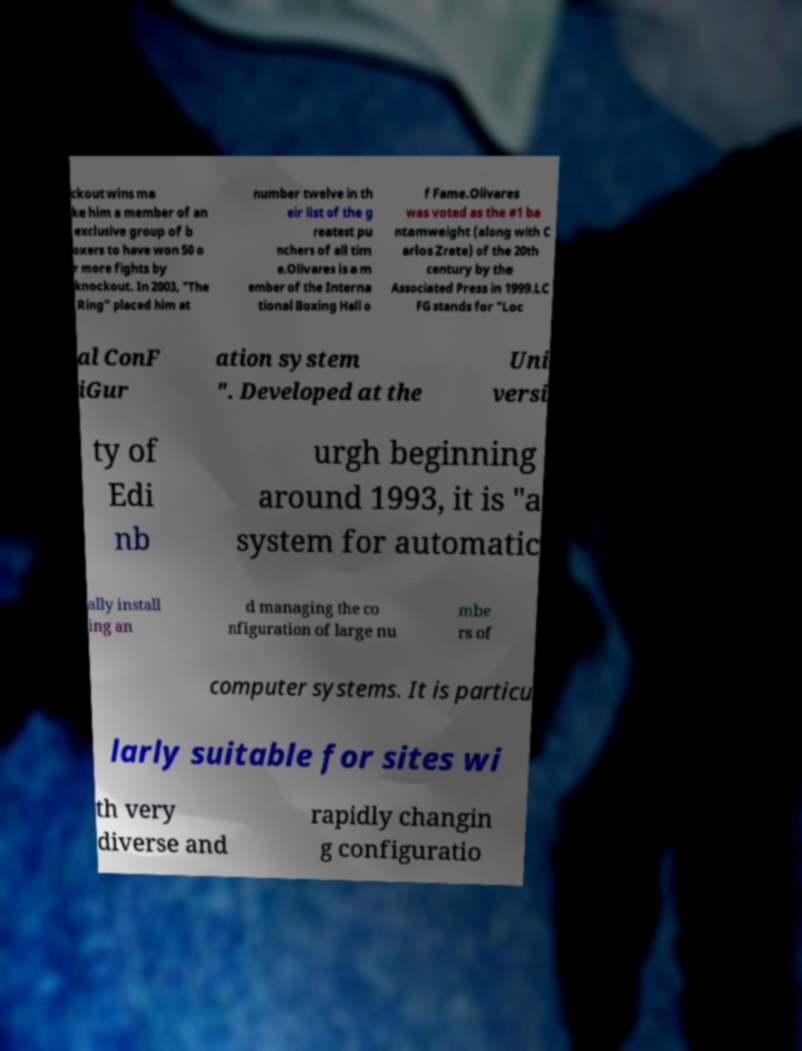I need the written content from this picture converted into text. Can you do that? ckout wins ma ke him a member of an exclusive group of b oxers to have won 50 o r more fights by knockout. In 2003, "The Ring" placed him at number twelve in th eir list of the g reatest pu nchers of all tim e.Olivares is a m ember of the Interna tional Boxing Hall o f Fame.Olivares was voted as the #1 ba ntamweight (along with C arlos Zrate) of the 20th century by the Associated Press in 1999.LC FG stands for "Loc al ConF iGur ation system ". Developed at the Uni versi ty of Edi nb urgh beginning around 1993, it is "a system for automatic ally install ing an d managing the co nfiguration of large nu mbe rs of computer systems. It is particu larly suitable for sites wi th very diverse and rapidly changin g configuratio 